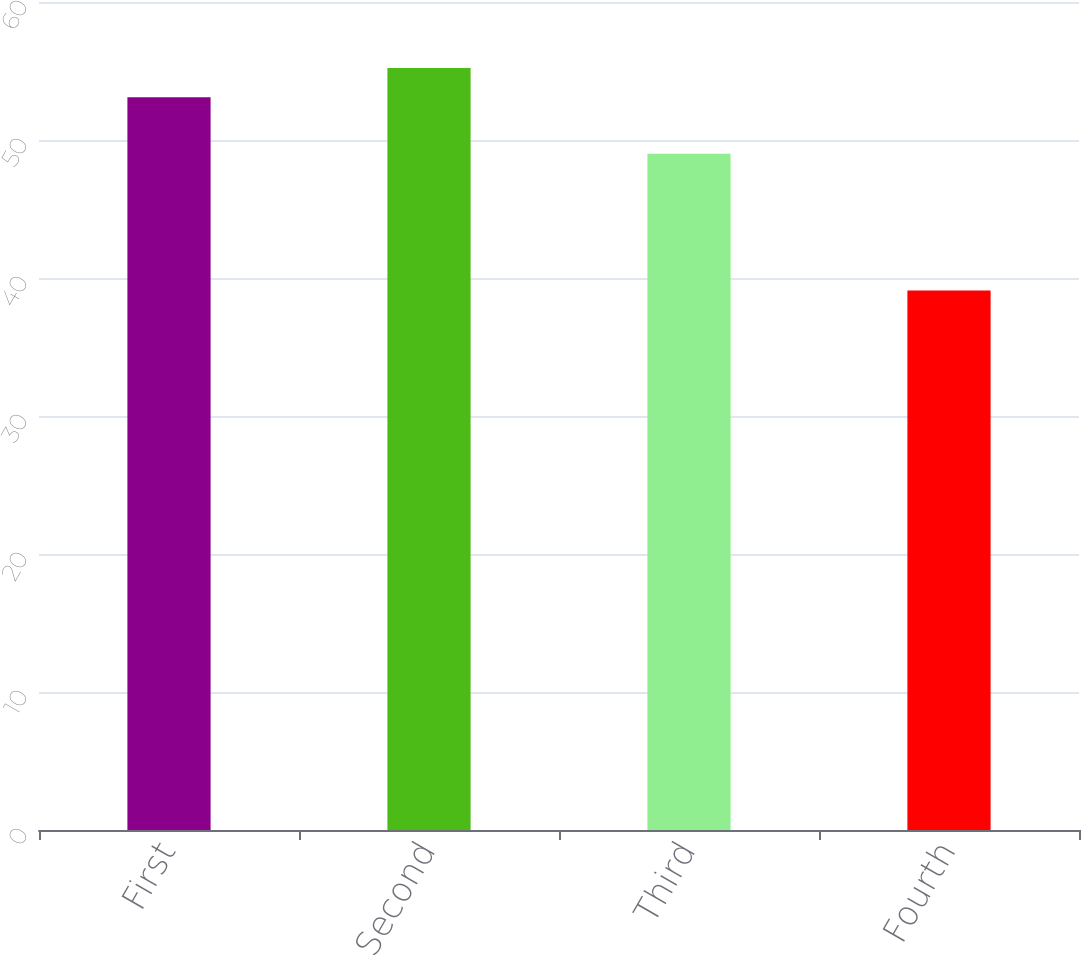<chart> <loc_0><loc_0><loc_500><loc_500><bar_chart><fcel>First<fcel>Second<fcel>Third<fcel>Fourth<nl><fcel>53.1<fcel>55.22<fcel>49.01<fcel>39.09<nl></chart> 